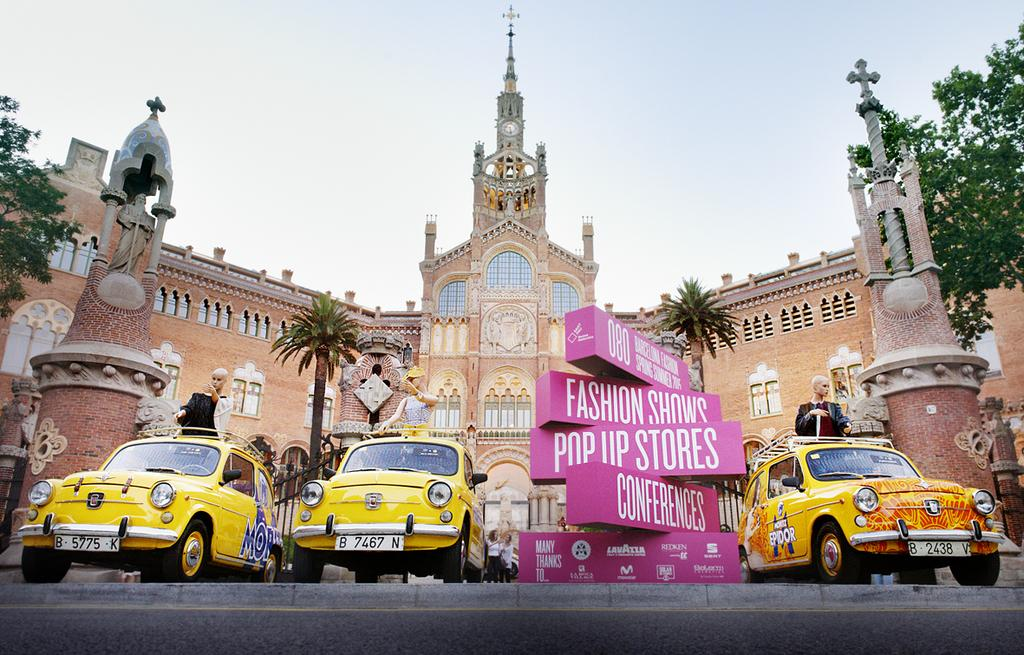<image>
Share a concise interpretation of the image provided. A row of pink taxis are in front of a palace and a pink sign says Fashion Shows, Pop Up Stories, and Conferences. 